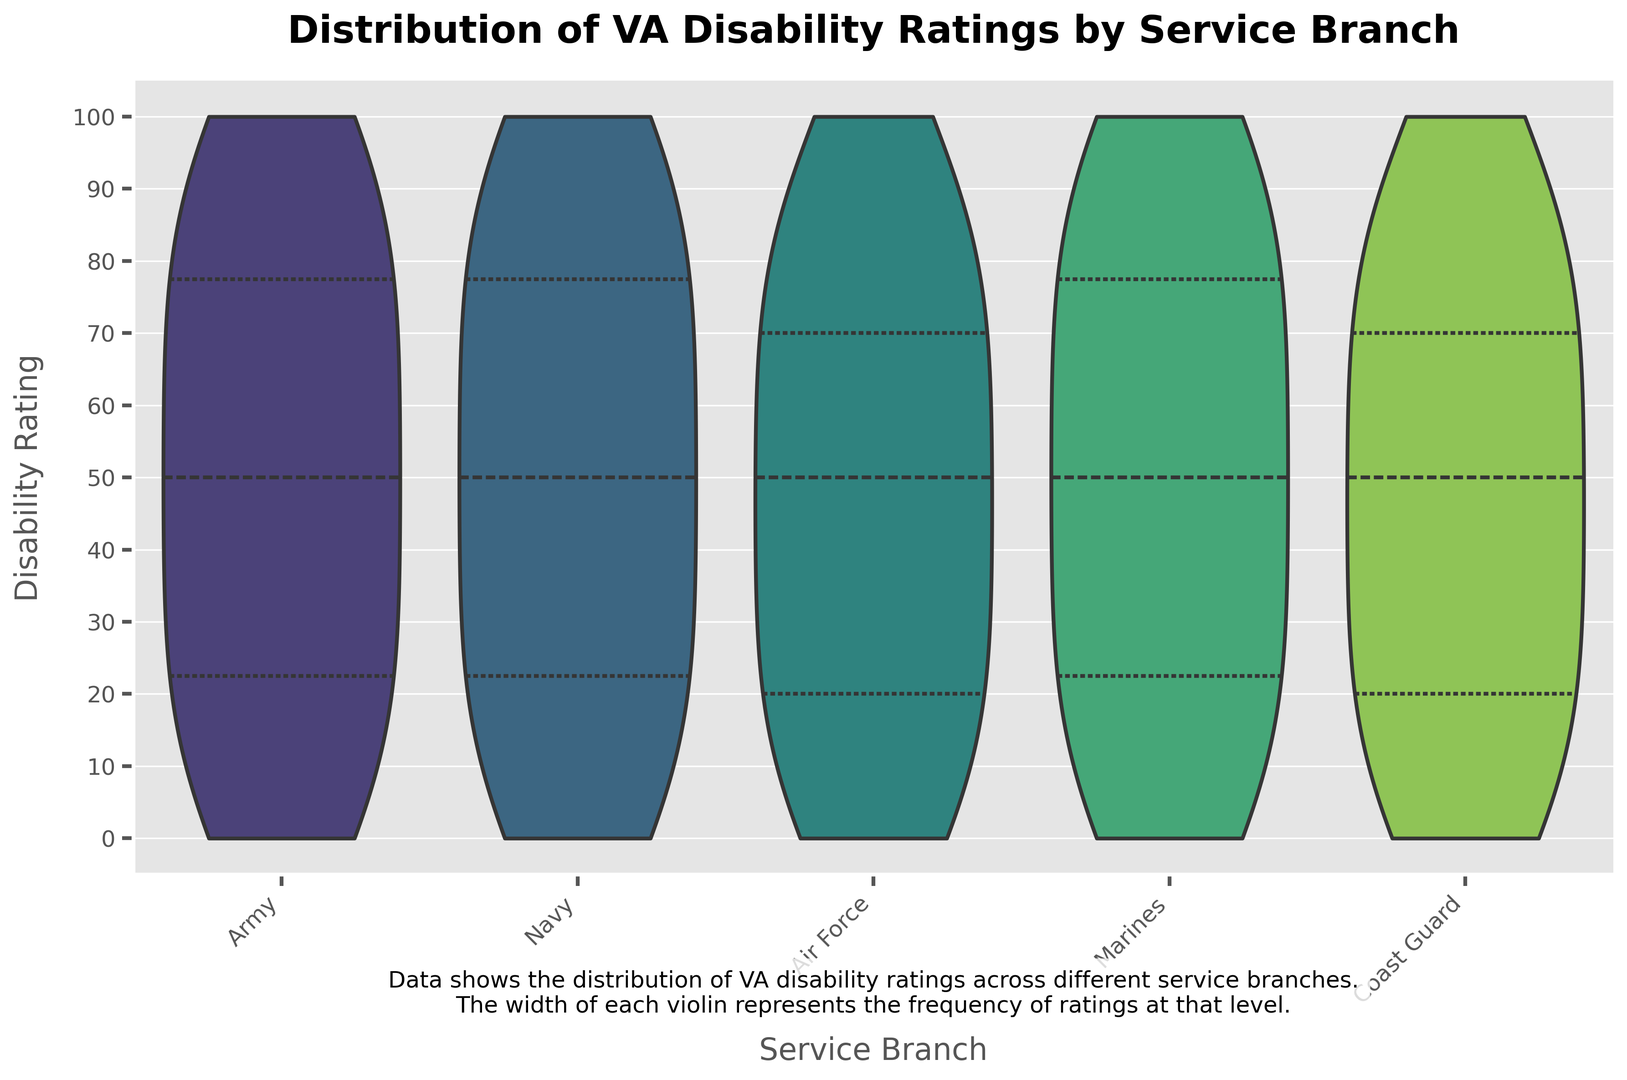Which service branch has the widest violin shape around the 100% disability rating? The width of the violin shape at any given point represents the frequency of ratings at that level. Looking at the figures, the Army seems to have the widest shape at the 100% disability rating, indicating that this branch has the highest frequency of 100% ratings.
Answer: Army What is the median disability rating for the Navy compared to the Air Force? In the violin plot, the median is often indicated by a white dot. By observing the positions of the white dots relative to the y-axis, we can compare the median disability ratings for the Navy and Air Force. Both branches have their median around the 50% mark.
Answer: Equal Which service branch has the most evenly distributed disability ratings? A violin plot showing a uniform width throughout indicates an even distribution. In the visual, the Coast Guard's violin plot has a relatively uniform width from 0% to 100%, suggesting a more even distribution compared to the other branches.
Answer: Coast Guard How do the interquartile ranges (IQR) of disability ratings for the Marines and Army compare? The interquartile range (IQR) is depicted by the spread of the thickest part of the violin plot. The Marines have a narrower IQR compared to the Army, indicating less variability in the middle 50% of the data.
Answer: Marines have a narrower IQR What's the most common disability rating range for the Air Force? The widest part of the Air Force's violin plot indicates the most common rating range. This part appears around 90%-100%.
Answer: 90%-100% Does any service branch have a bimodal distribution, and if so, which one(s)? A bimodal distribution would show two distinct bulges in the violin plot. The Marines appear to have two noticeable bulges, one around 0%-20% and another around 90%-100%.
Answer: Marines Which service branch has the least number of veterans with a 0% disability rating? The thinness at the very bottom of the violin plot corresponds to the 0% rating. The Coast Guard’s plot starts quite thin at the bottom, indicating fewer veterans with a 0% rating.
Answer: Coast Guard 